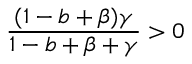Convert formula to latex. <formula><loc_0><loc_0><loc_500><loc_500>\frac { ( 1 - b + \beta ) \gamma } { 1 - b + \beta + \gamma } > 0</formula> 